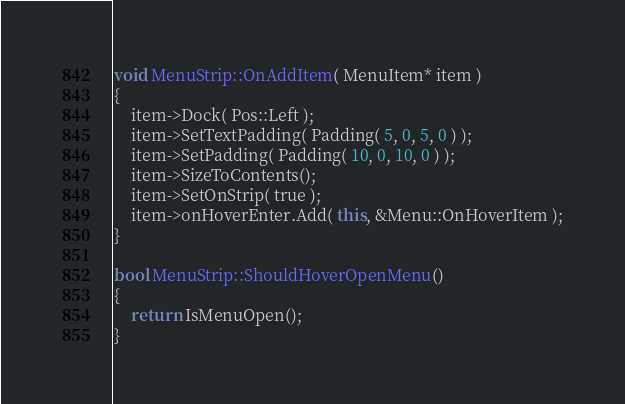<code> <loc_0><loc_0><loc_500><loc_500><_C++_>void MenuStrip::OnAddItem( MenuItem* item )
{
	item->Dock( Pos::Left );
	item->SetTextPadding( Padding( 5, 0, 5, 0 ) );
	item->SetPadding( Padding( 10, 0, 10, 0 ) );
	item->SizeToContents();
	item->SetOnStrip( true );
	item->onHoverEnter.Add( this, &Menu::OnHoverItem );
}

bool MenuStrip::ShouldHoverOpenMenu()
{
	return IsMenuOpen();
}</code> 